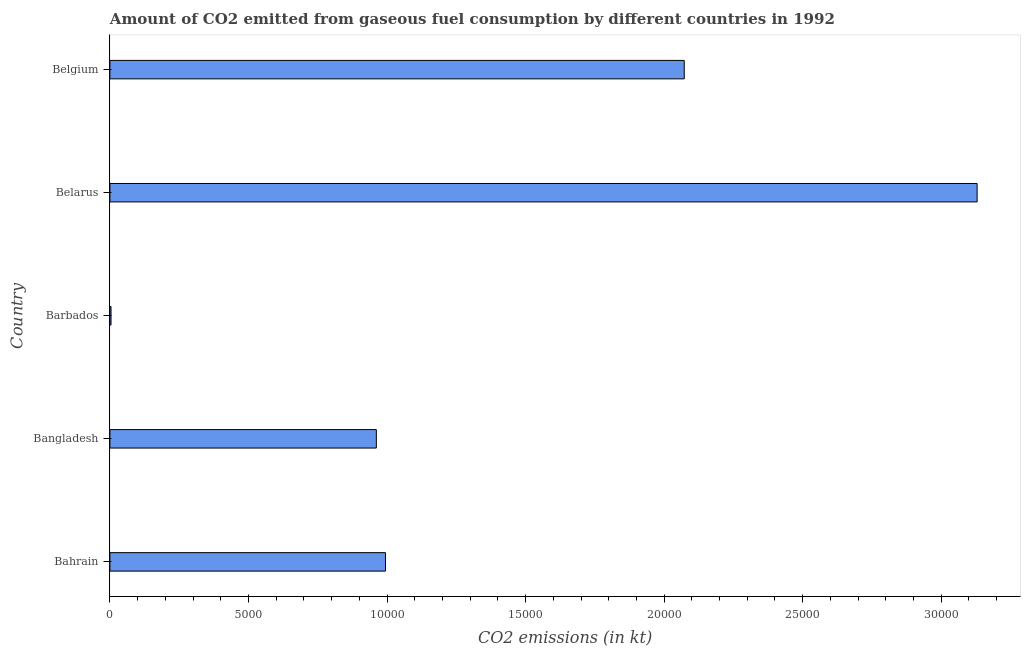Does the graph contain any zero values?
Your answer should be compact. No. What is the title of the graph?
Offer a terse response. Amount of CO2 emitted from gaseous fuel consumption by different countries in 1992. What is the label or title of the X-axis?
Your response must be concise. CO2 emissions (in kt). What is the label or title of the Y-axis?
Your answer should be compact. Country. What is the co2 emissions from gaseous fuel consumption in Bahrain?
Your response must be concise. 9944.9. Across all countries, what is the maximum co2 emissions from gaseous fuel consumption?
Offer a terse response. 3.13e+04. Across all countries, what is the minimum co2 emissions from gaseous fuel consumption?
Your answer should be compact. 40.34. In which country was the co2 emissions from gaseous fuel consumption maximum?
Provide a succinct answer. Belarus. In which country was the co2 emissions from gaseous fuel consumption minimum?
Give a very brief answer. Barbados. What is the sum of the co2 emissions from gaseous fuel consumption?
Your answer should be very brief. 7.16e+04. What is the difference between the co2 emissions from gaseous fuel consumption in Bangladesh and Belgium?
Make the answer very short. -1.11e+04. What is the average co2 emissions from gaseous fuel consumption per country?
Offer a very short reply. 1.43e+04. What is the median co2 emissions from gaseous fuel consumption?
Provide a succinct answer. 9944.9. In how many countries, is the co2 emissions from gaseous fuel consumption greater than 19000 kt?
Your answer should be very brief. 2. What is the ratio of the co2 emissions from gaseous fuel consumption in Barbados to that in Belgium?
Your response must be concise. 0. Is the difference between the co2 emissions from gaseous fuel consumption in Bahrain and Belarus greater than the difference between any two countries?
Provide a short and direct response. No. What is the difference between the highest and the second highest co2 emissions from gaseous fuel consumption?
Your answer should be compact. 1.06e+04. What is the difference between the highest and the lowest co2 emissions from gaseous fuel consumption?
Keep it short and to the point. 3.13e+04. How many bars are there?
Offer a terse response. 5. What is the CO2 emissions (in kt) in Bahrain?
Offer a terse response. 9944.9. What is the CO2 emissions (in kt) of Bangladesh?
Your answer should be compact. 9614.87. What is the CO2 emissions (in kt) of Barbados?
Provide a short and direct response. 40.34. What is the CO2 emissions (in kt) in Belarus?
Provide a short and direct response. 3.13e+04. What is the CO2 emissions (in kt) in Belgium?
Give a very brief answer. 2.07e+04. What is the difference between the CO2 emissions (in kt) in Bahrain and Bangladesh?
Keep it short and to the point. 330.03. What is the difference between the CO2 emissions (in kt) in Bahrain and Barbados?
Ensure brevity in your answer.  9904.57. What is the difference between the CO2 emissions (in kt) in Bahrain and Belarus?
Your answer should be compact. -2.13e+04. What is the difference between the CO2 emissions (in kt) in Bahrain and Belgium?
Your answer should be compact. -1.08e+04. What is the difference between the CO2 emissions (in kt) in Bangladesh and Barbados?
Offer a terse response. 9574.54. What is the difference between the CO2 emissions (in kt) in Bangladesh and Belarus?
Your response must be concise. -2.17e+04. What is the difference between the CO2 emissions (in kt) in Bangladesh and Belgium?
Your response must be concise. -1.11e+04. What is the difference between the CO2 emissions (in kt) in Barbados and Belarus?
Offer a terse response. -3.13e+04. What is the difference between the CO2 emissions (in kt) in Barbados and Belgium?
Provide a short and direct response. -2.07e+04. What is the difference between the CO2 emissions (in kt) in Belarus and Belgium?
Offer a terse response. 1.06e+04. What is the ratio of the CO2 emissions (in kt) in Bahrain to that in Bangladesh?
Make the answer very short. 1.03. What is the ratio of the CO2 emissions (in kt) in Bahrain to that in Barbados?
Offer a terse response. 246.54. What is the ratio of the CO2 emissions (in kt) in Bahrain to that in Belarus?
Your response must be concise. 0.32. What is the ratio of the CO2 emissions (in kt) in Bahrain to that in Belgium?
Your answer should be very brief. 0.48. What is the ratio of the CO2 emissions (in kt) in Bangladesh to that in Barbados?
Ensure brevity in your answer.  238.36. What is the ratio of the CO2 emissions (in kt) in Bangladesh to that in Belarus?
Your response must be concise. 0.31. What is the ratio of the CO2 emissions (in kt) in Bangladesh to that in Belgium?
Offer a terse response. 0.46. What is the ratio of the CO2 emissions (in kt) in Barbados to that in Belgium?
Ensure brevity in your answer.  0. What is the ratio of the CO2 emissions (in kt) in Belarus to that in Belgium?
Your answer should be compact. 1.51. 